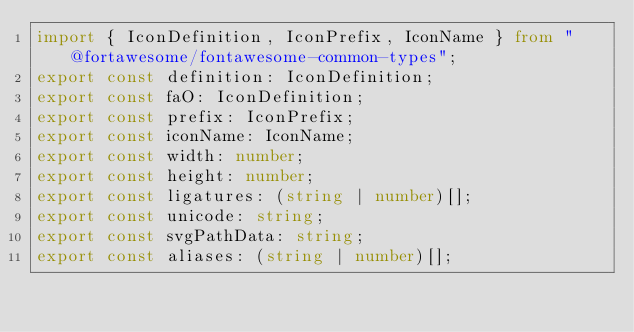Convert code to text. <code><loc_0><loc_0><loc_500><loc_500><_TypeScript_>import { IconDefinition, IconPrefix, IconName } from "@fortawesome/fontawesome-common-types";
export const definition: IconDefinition;
export const faO: IconDefinition;
export const prefix: IconPrefix;
export const iconName: IconName;
export const width: number;
export const height: number;
export const ligatures: (string | number)[];
export const unicode: string;
export const svgPathData: string;
export const aliases: (string | number)[];</code> 